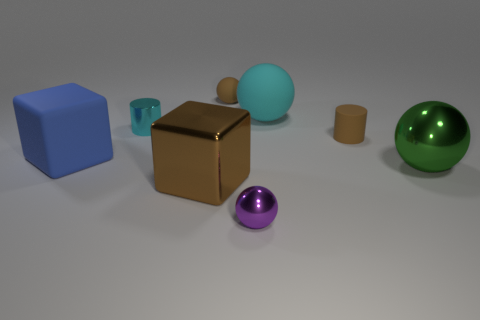How many big gray cubes are the same material as the green sphere?
Your answer should be compact. 0. What color is the cylinder that is the same material as the blue block?
Give a very brief answer. Brown. There is a cyan shiny cylinder; does it have the same size as the ball to the left of the purple shiny thing?
Your answer should be compact. Yes. There is a large green shiny object; what shape is it?
Make the answer very short. Sphere. How many big spheres have the same color as the tiny matte sphere?
Make the answer very short. 0. There is a small rubber thing that is the same shape as the tiny cyan metallic thing; what color is it?
Make the answer very short. Brown. How many shiny blocks are in front of the small cylinder that is in front of the small metal cylinder?
Provide a short and direct response. 1. What number of blocks are purple metallic objects or green things?
Make the answer very short. 0. Are any small cyan metallic cylinders visible?
Make the answer very short. Yes. The other shiny object that is the same shape as the tiny purple object is what size?
Provide a short and direct response. Large. 